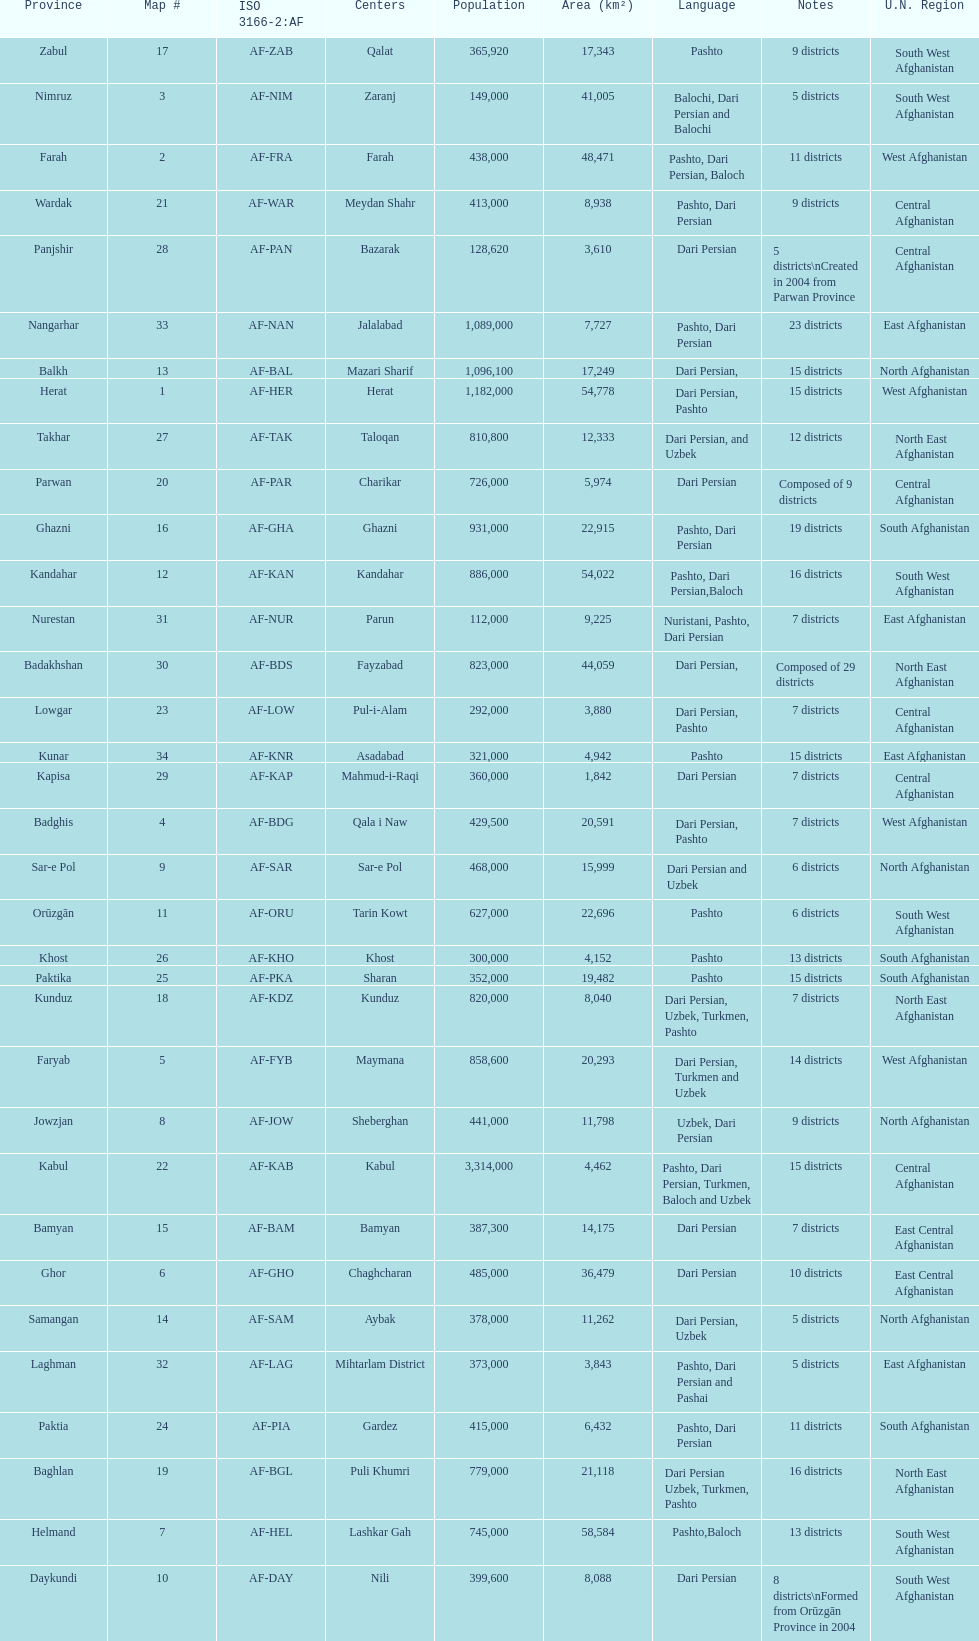What province in afghanistanhas the greatest population? Kabul. 